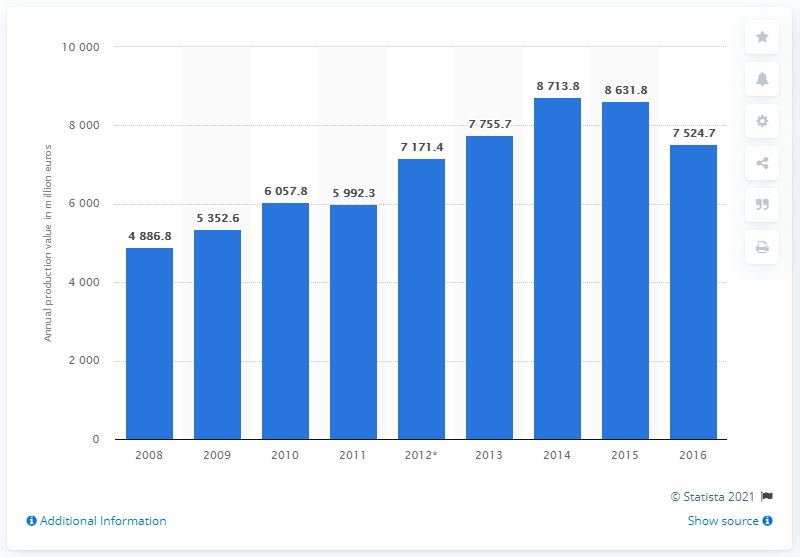Mention a couple of crucial points in this snapshot. In 2016, the annual production value of Luxembourg's ICT services sector was 7,524.7 million euros. 